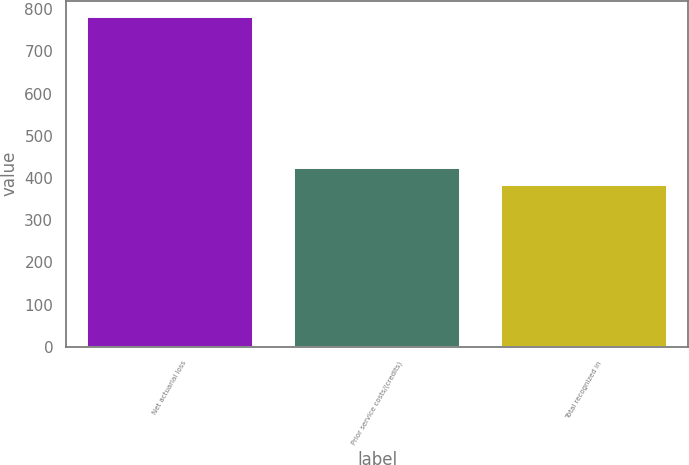<chart> <loc_0><loc_0><loc_500><loc_500><bar_chart><fcel>Net actuarial loss<fcel>Prior service costs/(credits)<fcel>Total recognized in<nl><fcel>781<fcel>423.7<fcel>384<nl></chart> 